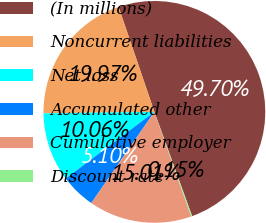Convert chart. <chart><loc_0><loc_0><loc_500><loc_500><pie_chart><fcel>(In millions)<fcel>Noncurrent liabilities<fcel>Net loss<fcel>Accumulated other<fcel>Cumulative employer<fcel>Discount rate<nl><fcel>49.7%<fcel>19.97%<fcel>10.06%<fcel>5.1%<fcel>15.01%<fcel>0.15%<nl></chart> 